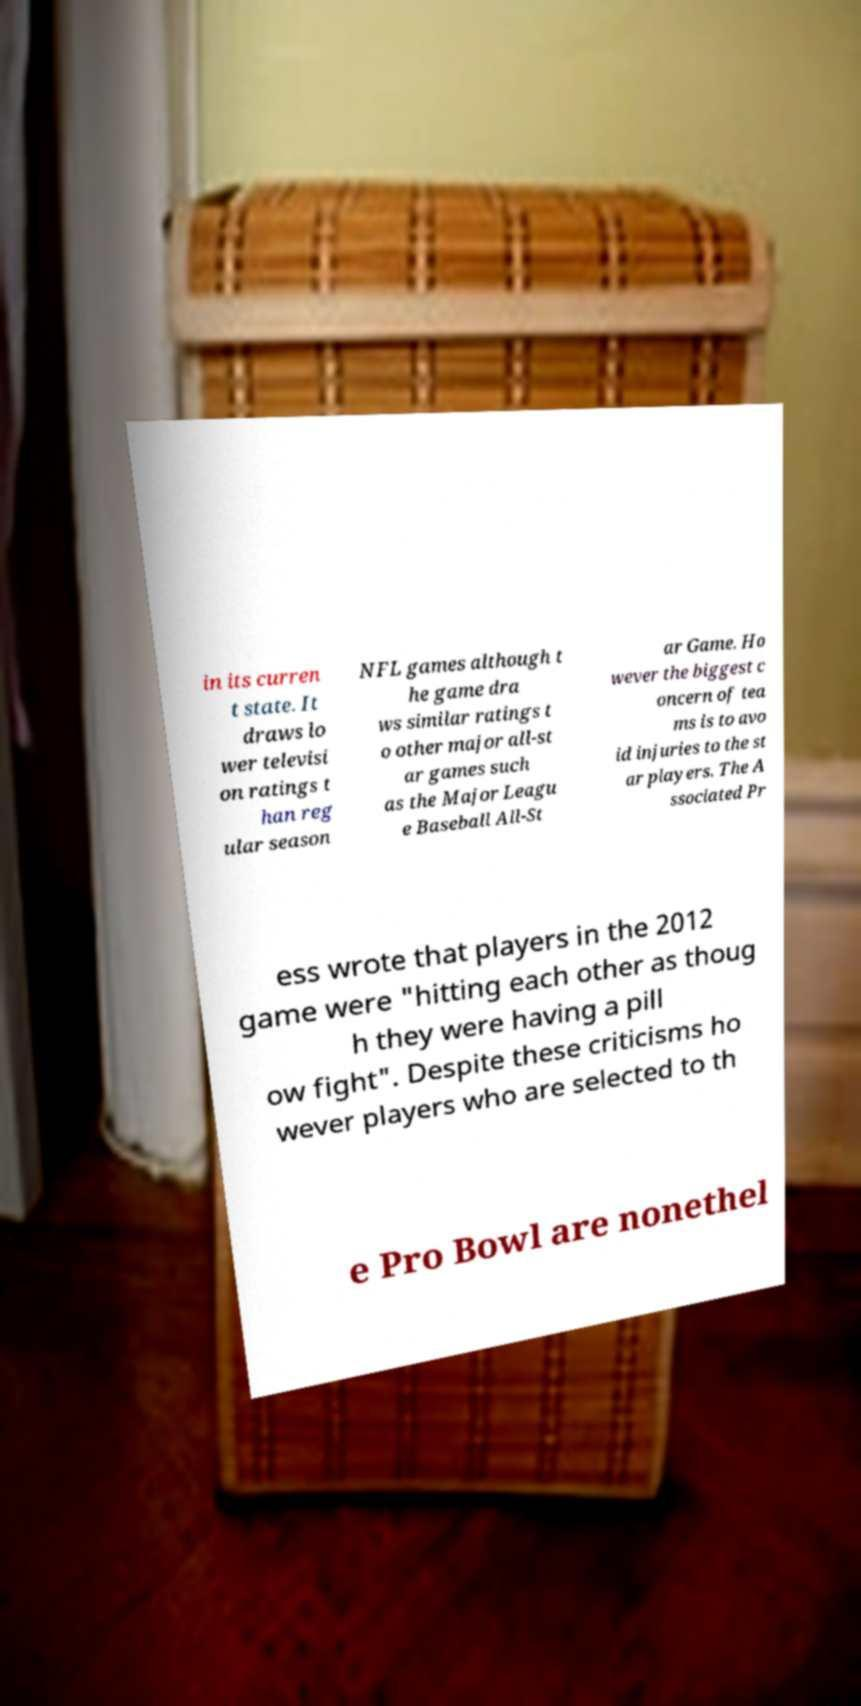Please identify and transcribe the text found in this image. in its curren t state. It draws lo wer televisi on ratings t han reg ular season NFL games although t he game dra ws similar ratings t o other major all-st ar games such as the Major Leagu e Baseball All-St ar Game. Ho wever the biggest c oncern of tea ms is to avo id injuries to the st ar players. The A ssociated Pr ess wrote that players in the 2012 game were "hitting each other as thoug h they were having a pill ow fight". Despite these criticisms ho wever players who are selected to th e Pro Bowl are nonethel 